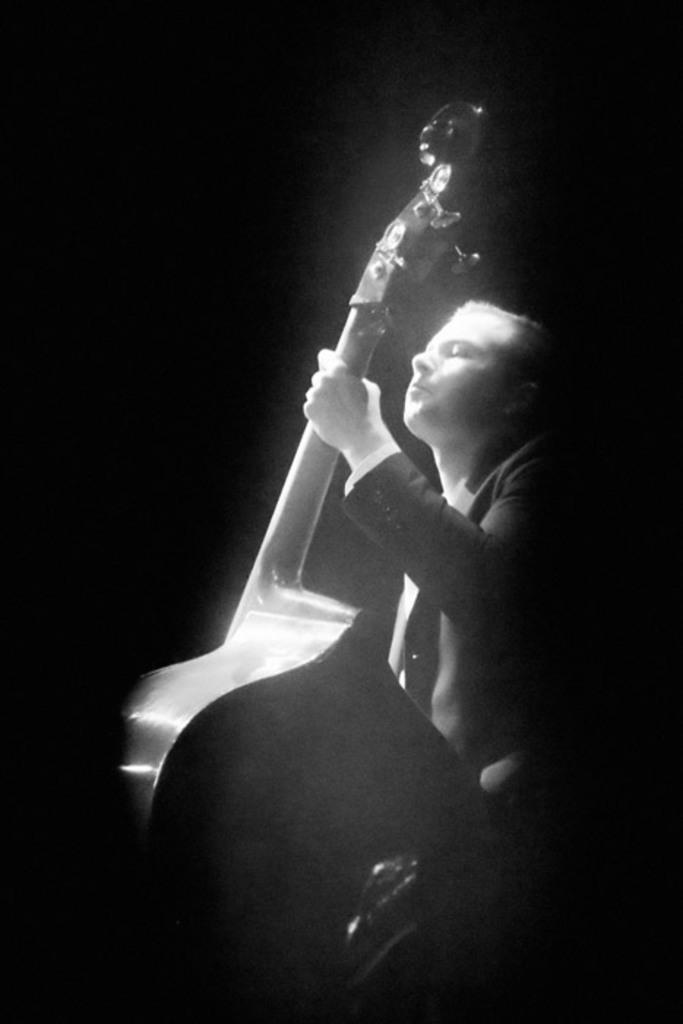What is happening in the image? There is a person in the image who is playing a musical instrument. Can you describe the musical instrument being played? The musical instrument is in the person's hands. How many babies are crawling on the person's throat in the image? There are no babies or throats present in the image; it features a person playing a musical instrument. 